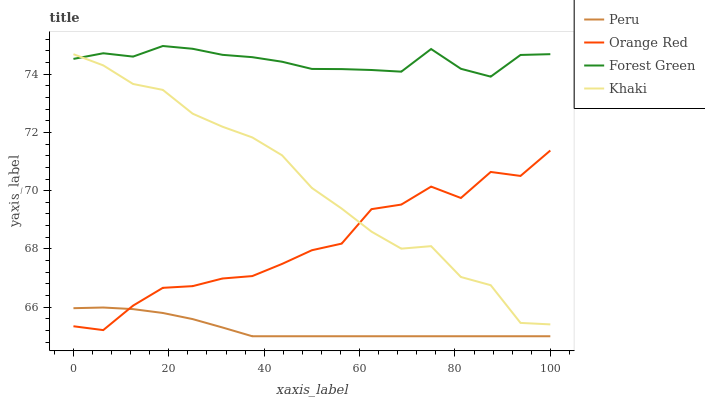Does Peru have the minimum area under the curve?
Answer yes or no. Yes. Does Forest Green have the maximum area under the curve?
Answer yes or no. Yes. Does Khaki have the minimum area under the curve?
Answer yes or no. No. Does Khaki have the maximum area under the curve?
Answer yes or no. No. Is Peru the smoothest?
Answer yes or no. Yes. Is Orange Red the roughest?
Answer yes or no. Yes. Is Khaki the smoothest?
Answer yes or no. No. Is Khaki the roughest?
Answer yes or no. No. Does Peru have the lowest value?
Answer yes or no. Yes. Does Khaki have the lowest value?
Answer yes or no. No. Does Forest Green have the highest value?
Answer yes or no. Yes. Does Khaki have the highest value?
Answer yes or no. No. Is Peru less than Khaki?
Answer yes or no. Yes. Is Forest Green greater than Peru?
Answer yes or no. Yes. Does Khaki intersect Forest Green?
Answer yes or no. Yes. Is Khaki less than Forest Green?
Answer yes or no. No. Is Khaki greater than Forest Green?
Answer yes or no. No. Does Peru intersect Khaki?
Answer yes or no. No. 